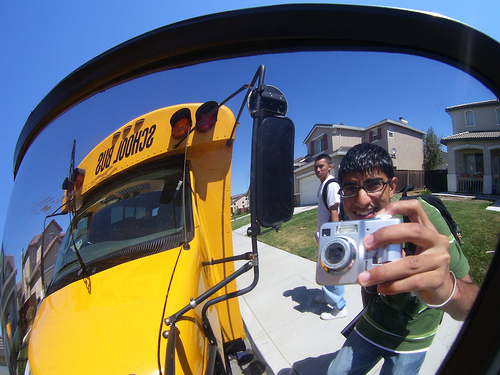What could the boy holding the camera be feeling in this moment? The boy holding the camera is likely feeling excited and joyful. His wide smile and the playful angle at which the photo is taken suggest he is enjoying the moment and may be eager to capture fun memories with his friends. Why might they be taking pictures in front of the school bus? Taking pictures in front of the school bus could signify a memorable moment for the boys, perhaps marking the start or end of a school year, a special field trip, or just capturing the joy of a regular school day. The bus also serves as a nostalgic symbol of school life. Imagine a creative story for the picture: How did the boys end up taking this photo? On a sunny morning, a group of friends decided to create a photo diary of their school adventures. As they gathered at the bus stop, one boy pulled out his camera, aiming to capture the essence of their daily routine. With laughter in the air, they struck spontaneous poses. The boy with the camera, aspiring to be a budding photographer, suggested an artistic shot - capturing the bus's reflection for a unique perspective. This activity turned into a mini photo session, where each friend took turns behind the camera, blending creativity with companionship on an ordinary yet memorable school day. Describe a realistic scenario related to the image: Each boy's thoughts as they prepare for a school day. The boy in the green shirt thinks about his upcoming math test. He feels a mixture of excitement and nervousness, hoping to do well. As he takes out his camera, he decides to take a quick picture to lighten the mood and capture the morning's vibe. His friend in the white shirt is more relaxed, thinking about catching up with classmates and the soccer game after school. Both boys find solace in their morning camaraderie, using the photo session as a brief distraction from their busy day ahead. 